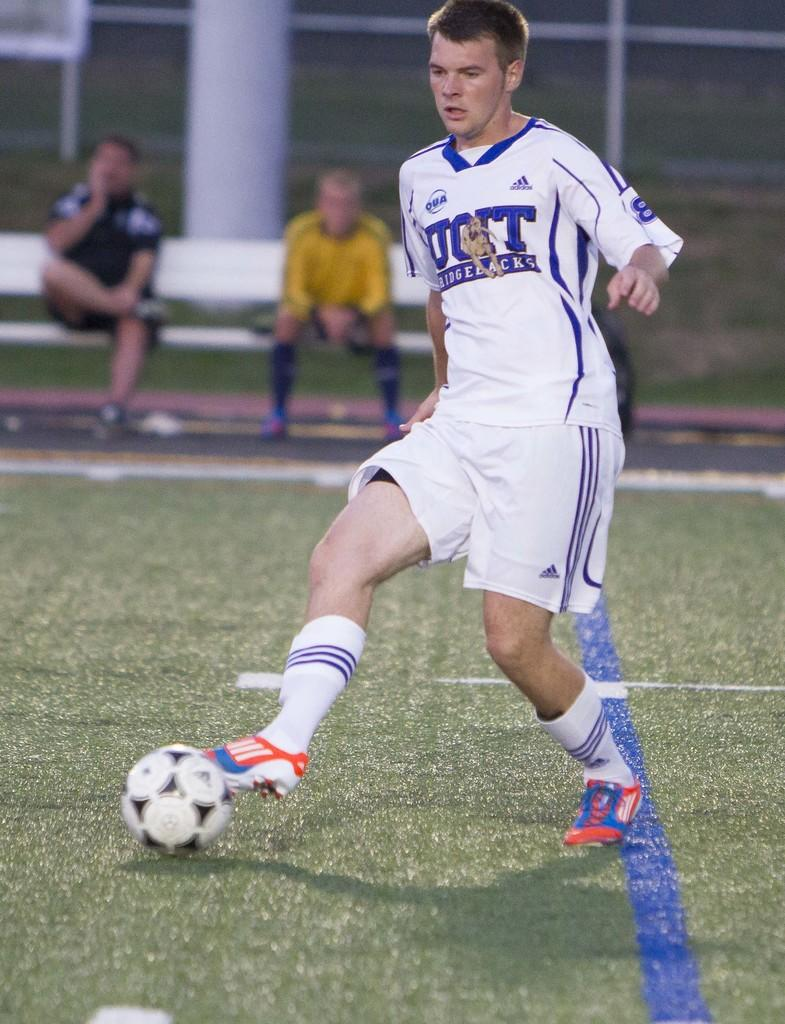<image>
Create a compact narrative representing the image presented. Soccer player with the word "Ridgebacks" on his jersey. 